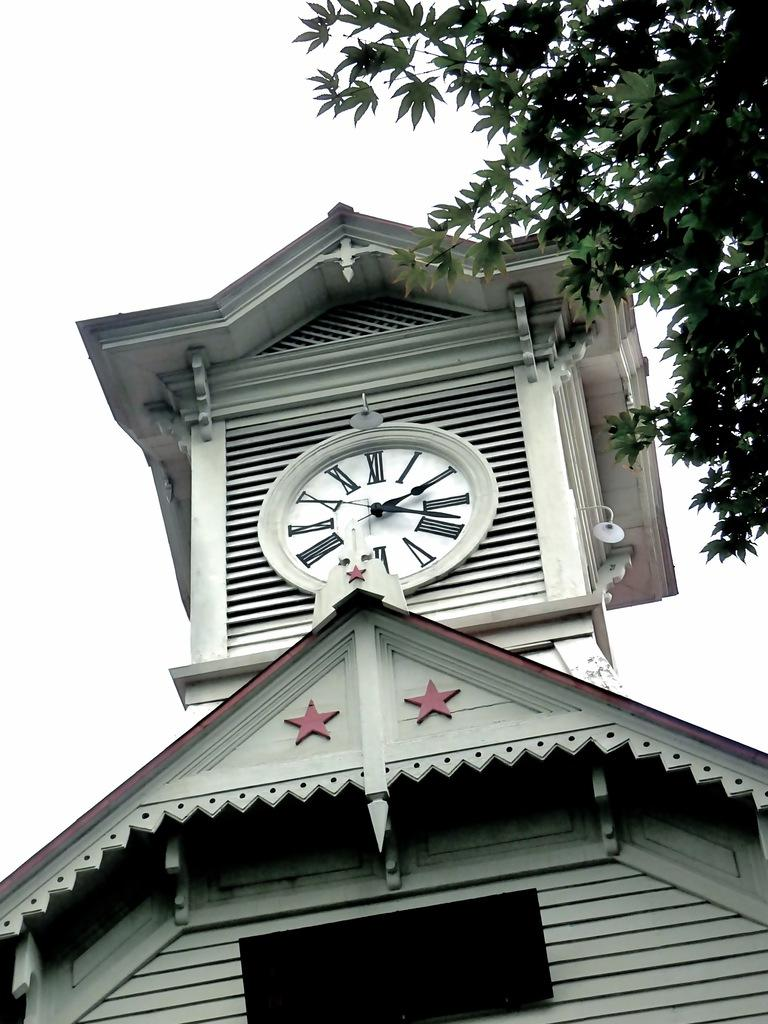<image>
Write a terse but informative summary of the picture. A courthouse type clock that says it is seventeen after two. 